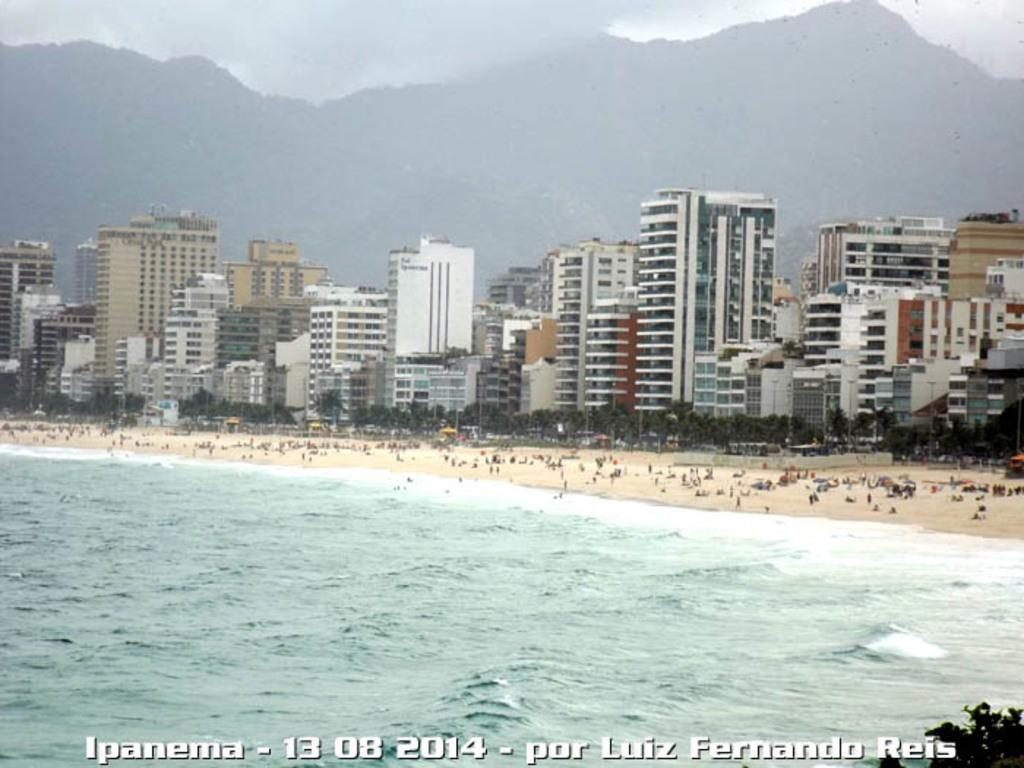What type of structures can be seen in the image? There are many buildings in the image. What natural elements are present in the image? There are trees and mountains in the image. What is visible at the top of the image? The sky is visible at the top of the image. What type of landscape can be seen at the bottom of the image? There is a beach and a waterpark at the bottom of the image. Can you hear the fang of the sofa in the image? There is no sofa or fang present in the image, so it is not possible to hear them. 